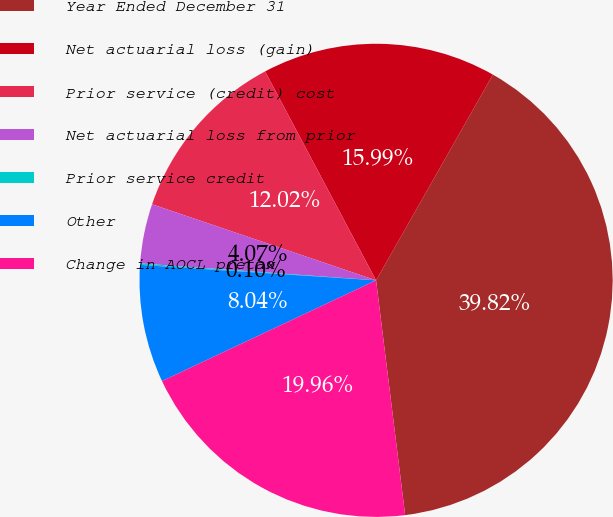Convert chart. <chart><loc_0><loc_0><loc_500><loc_500><pie_chart><fcel>Year Ended December 31<fcel>Net actuarial loss (gain)<fcel>Prior service (credit) cost<fcel>Net actuarial loss from prior<fcel>Prior service credit<fcel>Other<fcel>Change in AOCL pretax<nl><fcel>39.82%<fcel>15.99%<fcel>12.02%<fcel>4.07%<fcel>0.1%<fcel>8.04%<fcel>19.96%<nl></chart> 